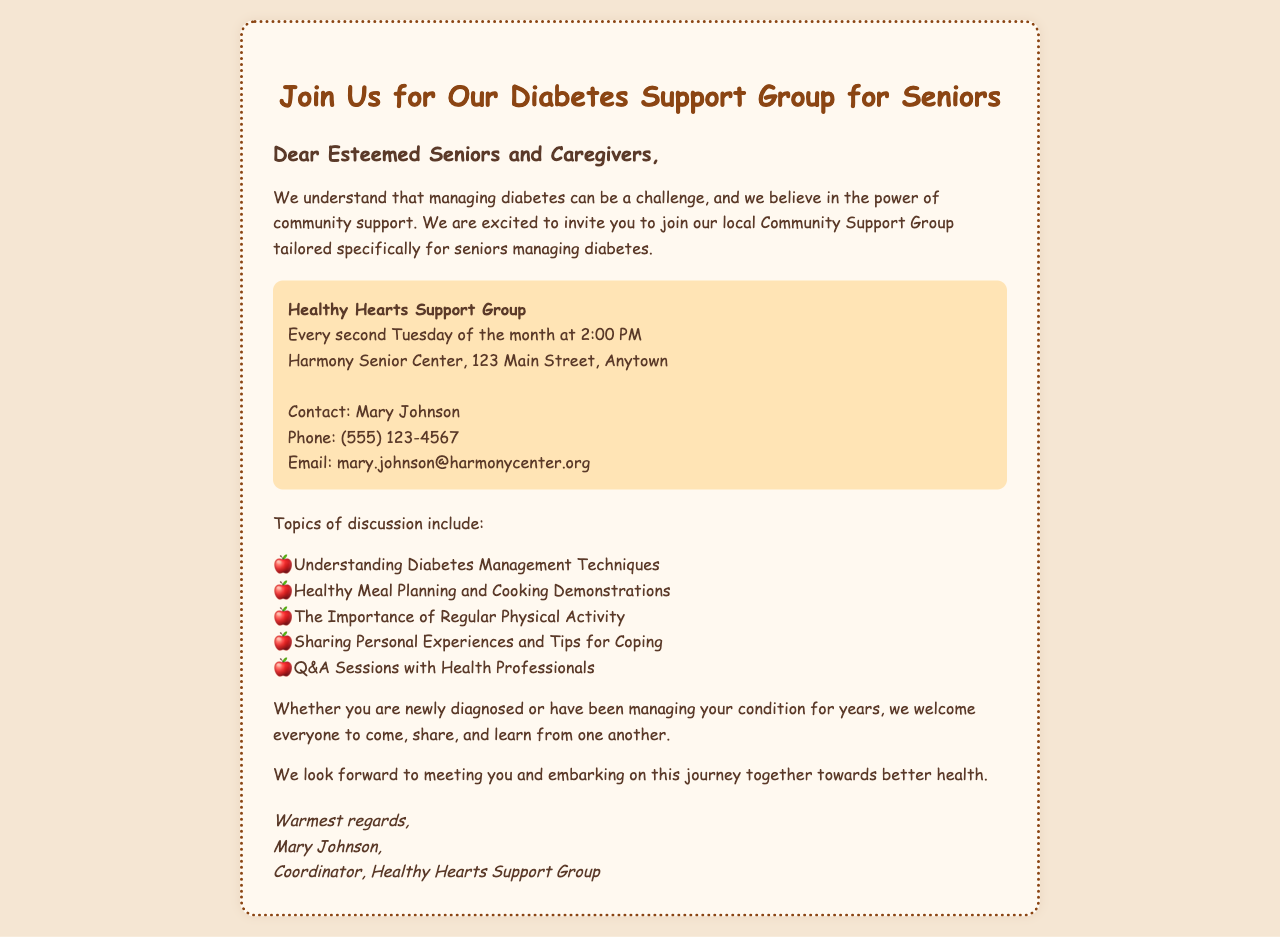What is the name of the support group? The name of the support group is stated in the document as "Healthy Hearts Support Group."
Answer: Healthy Hearts Support Group When does the support group meet? The document states that the support group meets "Every second Tuesday of the month at 2:00 PM."
Answer: Every second Tuesday of the month at 2:00 PM Where is the location of the Harmony Senior Center? The document specifies the address as "123 Main Street, Anytown."
Answer: 123 Main Street, Anytown Who is the contact person for the group? The contact person mentioned in the document is "Mary Johnson."
Answer: Mary Johnson What is one of the topics discussed in the group? The document lists several topics, one of which is "Understanding Diabetes Management Techniques."
Answer: Understanding Diabetes Management Techniques How often does the group meet? The document indicates that the group meets once a month.
Answer: Once a month What is the phone number to contact for more information? The document provides a phone number, which is "(555) 123-4567."
Answer: (555) 123-4567 What type of activities will be included in the group? The document mentions "Healthy Meal Planning and Cooking Demonstrations" as an included activity.
Answer: Healthy Meal Planning and Cooking Demonstrations 